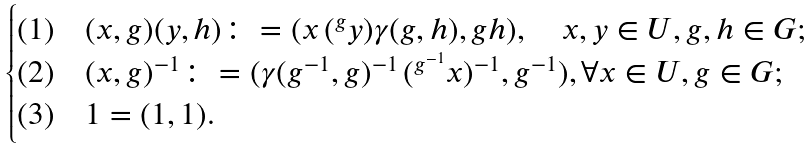<formula> <loc_0><loc_0><loc_500><loc_500>\begin{cases} ( 1 ) \quad ( x , g ) ( y , h ) \colon = ( x \, ( { ^ { g } y } ) \gamma ( g , h ) , g h ) , \quad x , y \in U , g , h \in G ; \\ ( 2 ) \quad ( x , g ) ^ { - 1 } \colon = ( { \gamma ( g ^ { - 1 } , g ) ^ { - 1 } } \, ( { ^ { g ^ { - 1 } } x } ) ^ { - 1 } , g ^ { - 1 } ) , \forall x \in U , g \in G ; \\ ( 3 ) \quad 1 = ( 1 , 1 ) . \end{cases}</formula> 